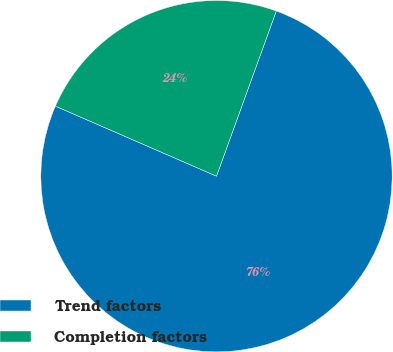Convert chart to OTSL. <chart><loc_0><loc_0><loc_500><loc_500><pie_chart><fcel>Trend factors<fcel>Completion factors<nl><fcel>76.0%<fcel>24.0%<nl></chart> 